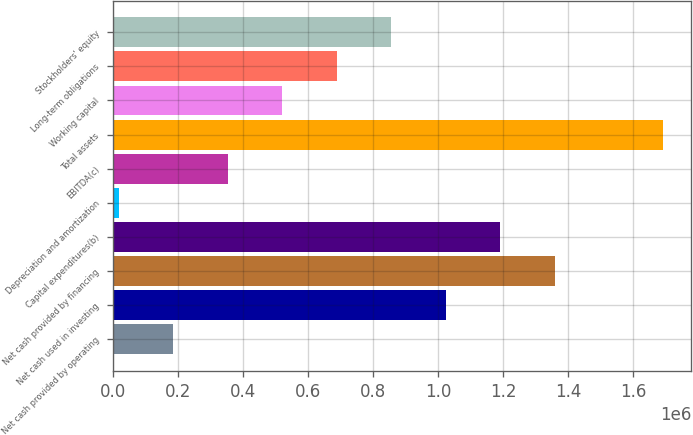Convert chart to OTSL. <chart><loc_0><loc_0><loc_500><loc_500><bar_chart><fcel>Net cash provided by operating<fcel>Net cash used in investing<fcel>Net cash provided by financing<fcel>Capital expenditures(b)<fcel>Depreciation and amortization<fcel>EBITDA(c)<fcel>Total assets<fcel>Working capital<fcel>Long-term obligations<fcel>Stockholders' equity<nl><fcel>185482<fcel>1.0228e+06<fcel>1.35773e+06<fcel>1.19026e+06<fcel>18018<fcel>352945<fcel>1.69266e+06<fcel>520409<fcel>687873<fcel>855336<nl></chart> 